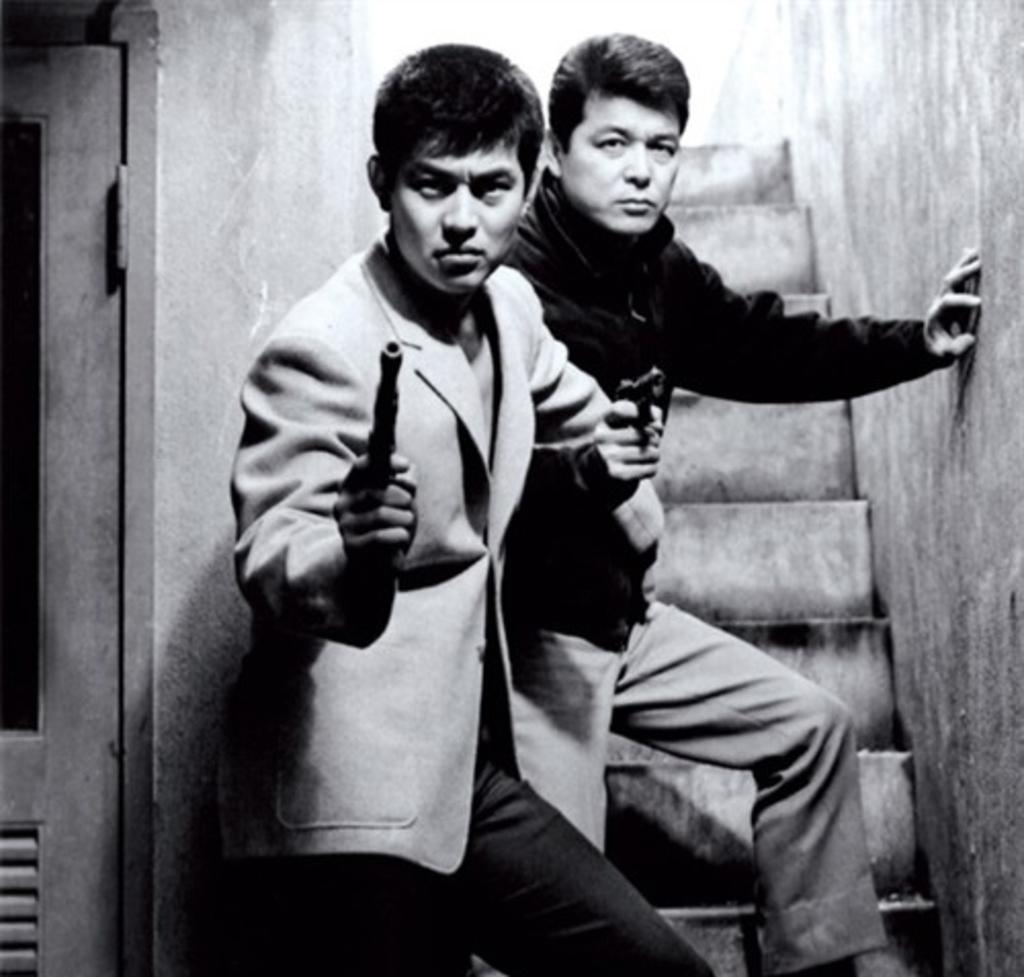What is the color scheme of the image? The image is black and white. How many people are in the image? There are two men in the image. Where are the men located in the image? The men are standing on the steps. What are the men holding in their hands? The men are holding guns in their hands. What can be seen on the left side of the image? There is a door on the left side of the image. What type of crack can be seen on the canvas in the image? There is no canvas or crack present in the image. 